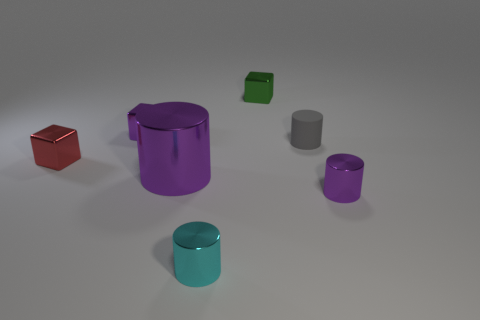Is there anything else that is the same size as the cyan cylinder?
Keep it short and to the point. Yes. What number of other things are the same shape as the small cyan shiny object?
Offer a terse response. 3. There is a small purple thing that is to the right of the tiny cyan metal cylinder; what shape is it?
Provide a short and direct response. Cylinder. Do the tiny green thing and the tiny purple object that is right of the green cube have the same shape?
Keep it short and to the point. No. There is a object that is both in front of the small red shiny cube and right of the tiny green metal block; how big is it?
Keep it short and to the point. Small. What is the color of the tiny thing that is both to the right of the big purple cylinder and behind the gray matte object?
Keep it short and to the point. Green. Are there any other things that are made of the same material as the purple block?
Give a very brief answer. Yes. Is the number of tiny green blocks behind the big metal thing less than the number of small purple metallic blocks in front of the red metallic cube?
Offer a terse response. No. Is there anything else that has the same color as the large shiny thing?
Ensure brevity in your answer.  Yes. The small cyan object is what shape?
Ensure brevity in your answer.  Cylinder. 